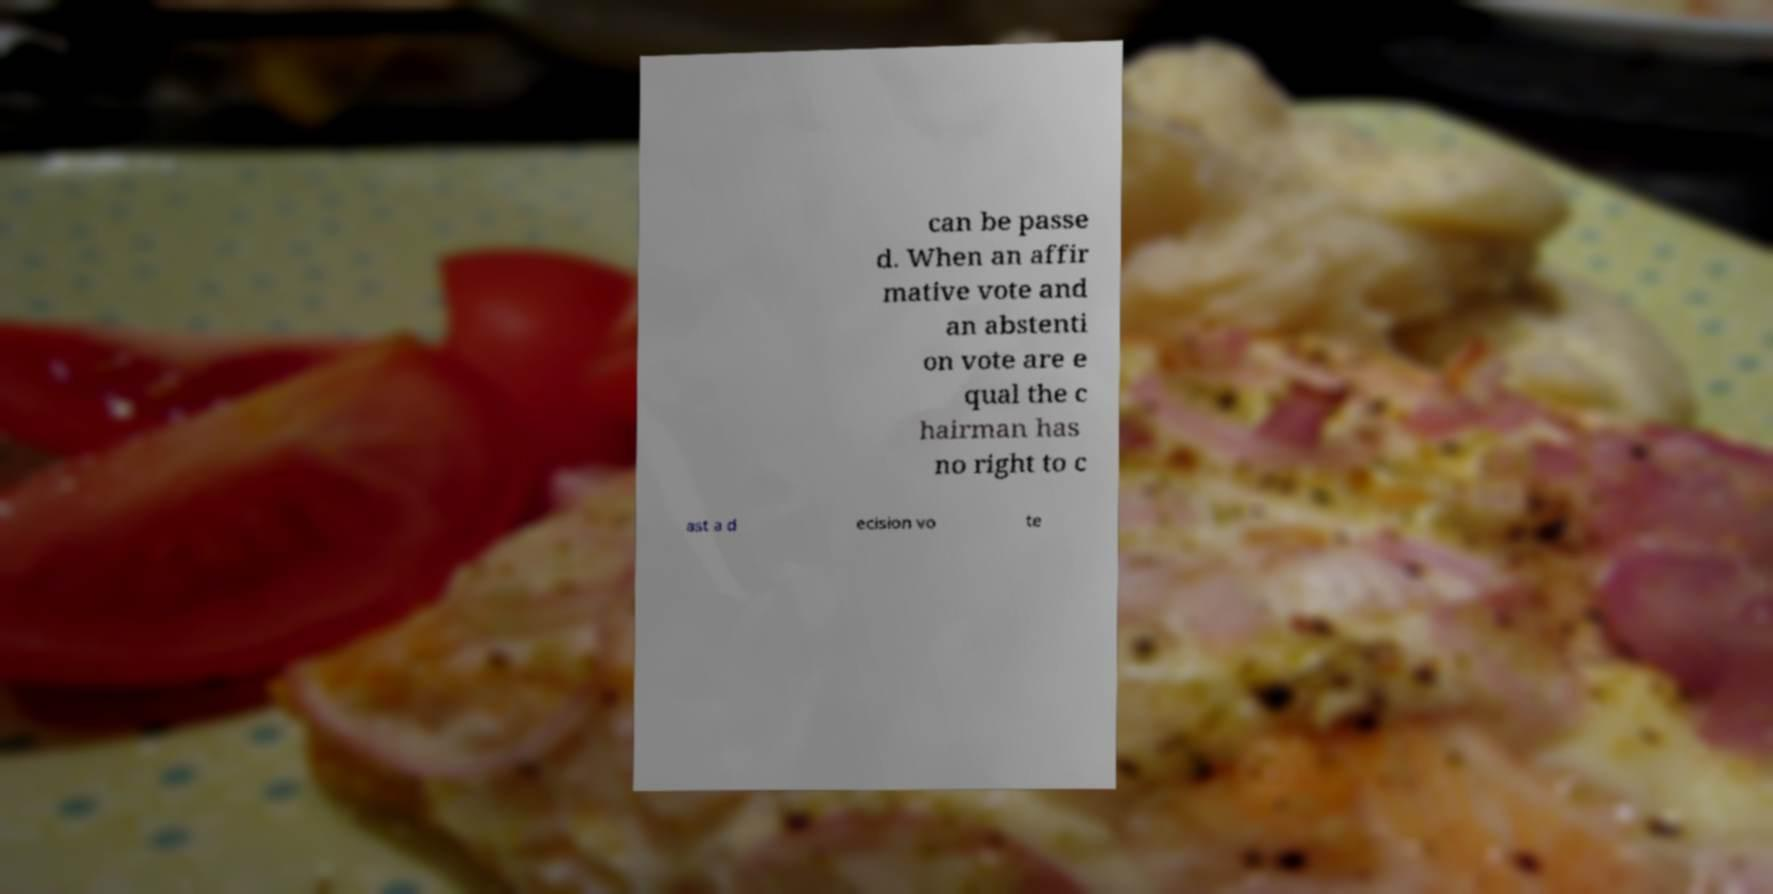Please read and relay the text visible in this image. What does it say? can be passe d. When an affir mative vote and an abstenti on vote are e qual the c hairman has no right to c ast a d ecision vo te 